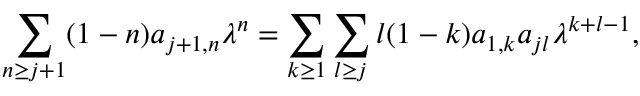<formula> <loc_0><loc_0><loc_500><loc_500>\sum _ { n \geq j + 1 } ( 1 - n ) a _ { j + 1 , n } \lambda ^ { n } = \sum _ { k \geq 1 } \sum _ { l \geq j } l ( 1 - k ) a _ { 1 , k } a _ { j l } \lambda ^ { k + l - 1 } ,</formula> 